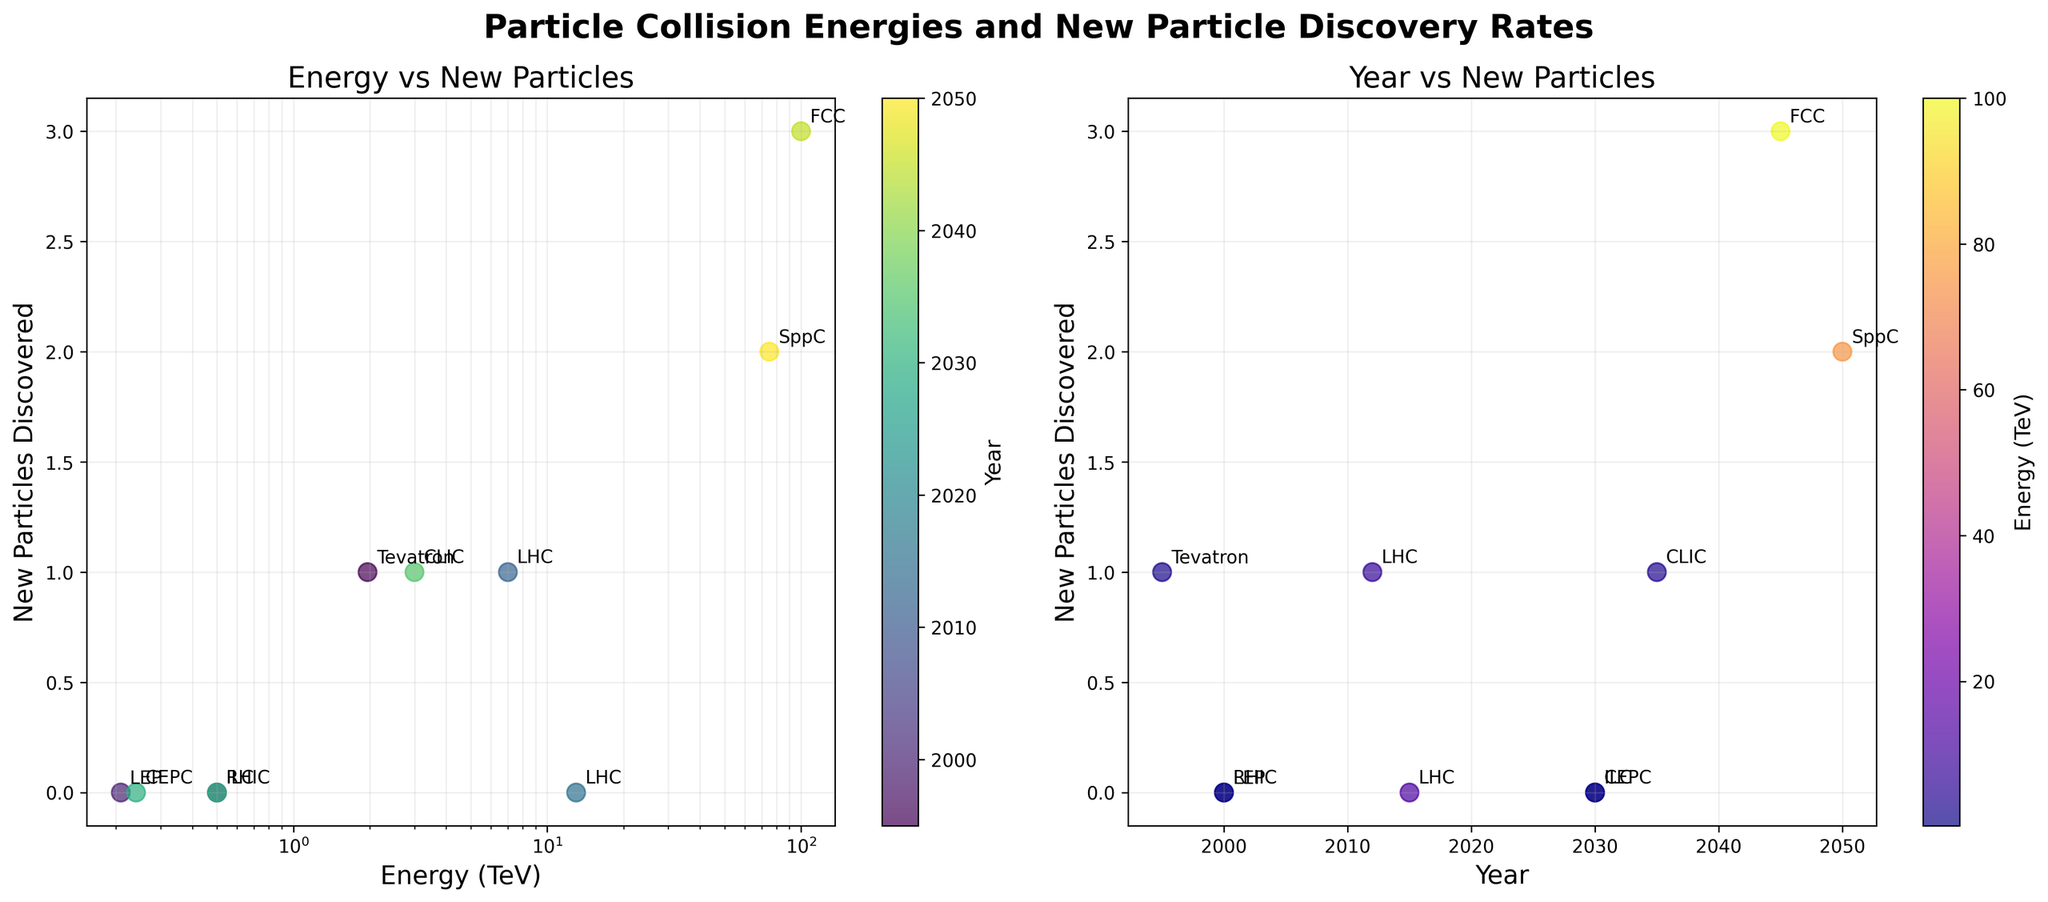What is the title of the left scatter plot? The title is displayed directly above the left scatter plot. It reads "Energy vs New Particles".
Answer: Energy vs New Particles How many data points are there in the right scatter plot? Each dot in the right scatter plot represents a data point. Counting these dots, we see there are 10 data points.
Answer: 10 Which particle accelerator discovered the most new particles? By examining both scatter plots, we can see that the data point (100 TeV, 3 new particles) corresponds to the FCC, labeled in both plots.
Answer: FCC Compare the new particles discovered by LHC at 7 TeV with LHC at 13 TeV. Which had more discoveries? Refer to the points labeled 'LHC' in the left scatter plot. The point (7 TeV, 1 new particle) has more discoveries than (13 TeV, 0 new particles).
Answer: LHC at 7 TeV What consistent trend, if any, can be observed between collision energy and new particle discoveries? Observing the left scatter plot, higher energy levels sometimes correlate to more discoveries, exemplified by FCC at 100 TeV discovering 3 particles.
Answer: Higher energies often correlate with more discoveries In what year did Tevatron discover a new particle and how many did it find? Looking at the right scatter plot, find the point corresponding to 'Tevatron' and note its label and position. It shows Tevatron discovered 1 new particle in 1995.
Answer: 1995 and 1 new particle Which color represents the earliest year in the left scatter plot? The left scatter plot uses a color bar scale based on years. The earliest year (1995) is represented by a darker color on the viridis colormap.
Answer: Darker color How many accelerators discovered new particles in the 21st century (after the year 2000)? Referring to the right scatter plot and counting the discoveries after the year 2000, LHC (2012, 1 particle), CLIC (2035, 1 particle), FCC (2045, 3 particles), SppC (2050, 2 particles). Thus, four discoveries.
Answer: 4 accelerators What was the energy level of CLIC, and in which year did it make a discovery? By examining the plotted data, CLIC is marked at (3 TeV, 1 discovery) and the corresponding year from the right plot is 2035.
Answer: 3 TeV and 2035 Is there a linear scale or log scale on the x-axis of the left scatter plot? The x-axis label and grid line spacing in the left scatter plot indicate a logarithmic scale.
Answer: Log scale 